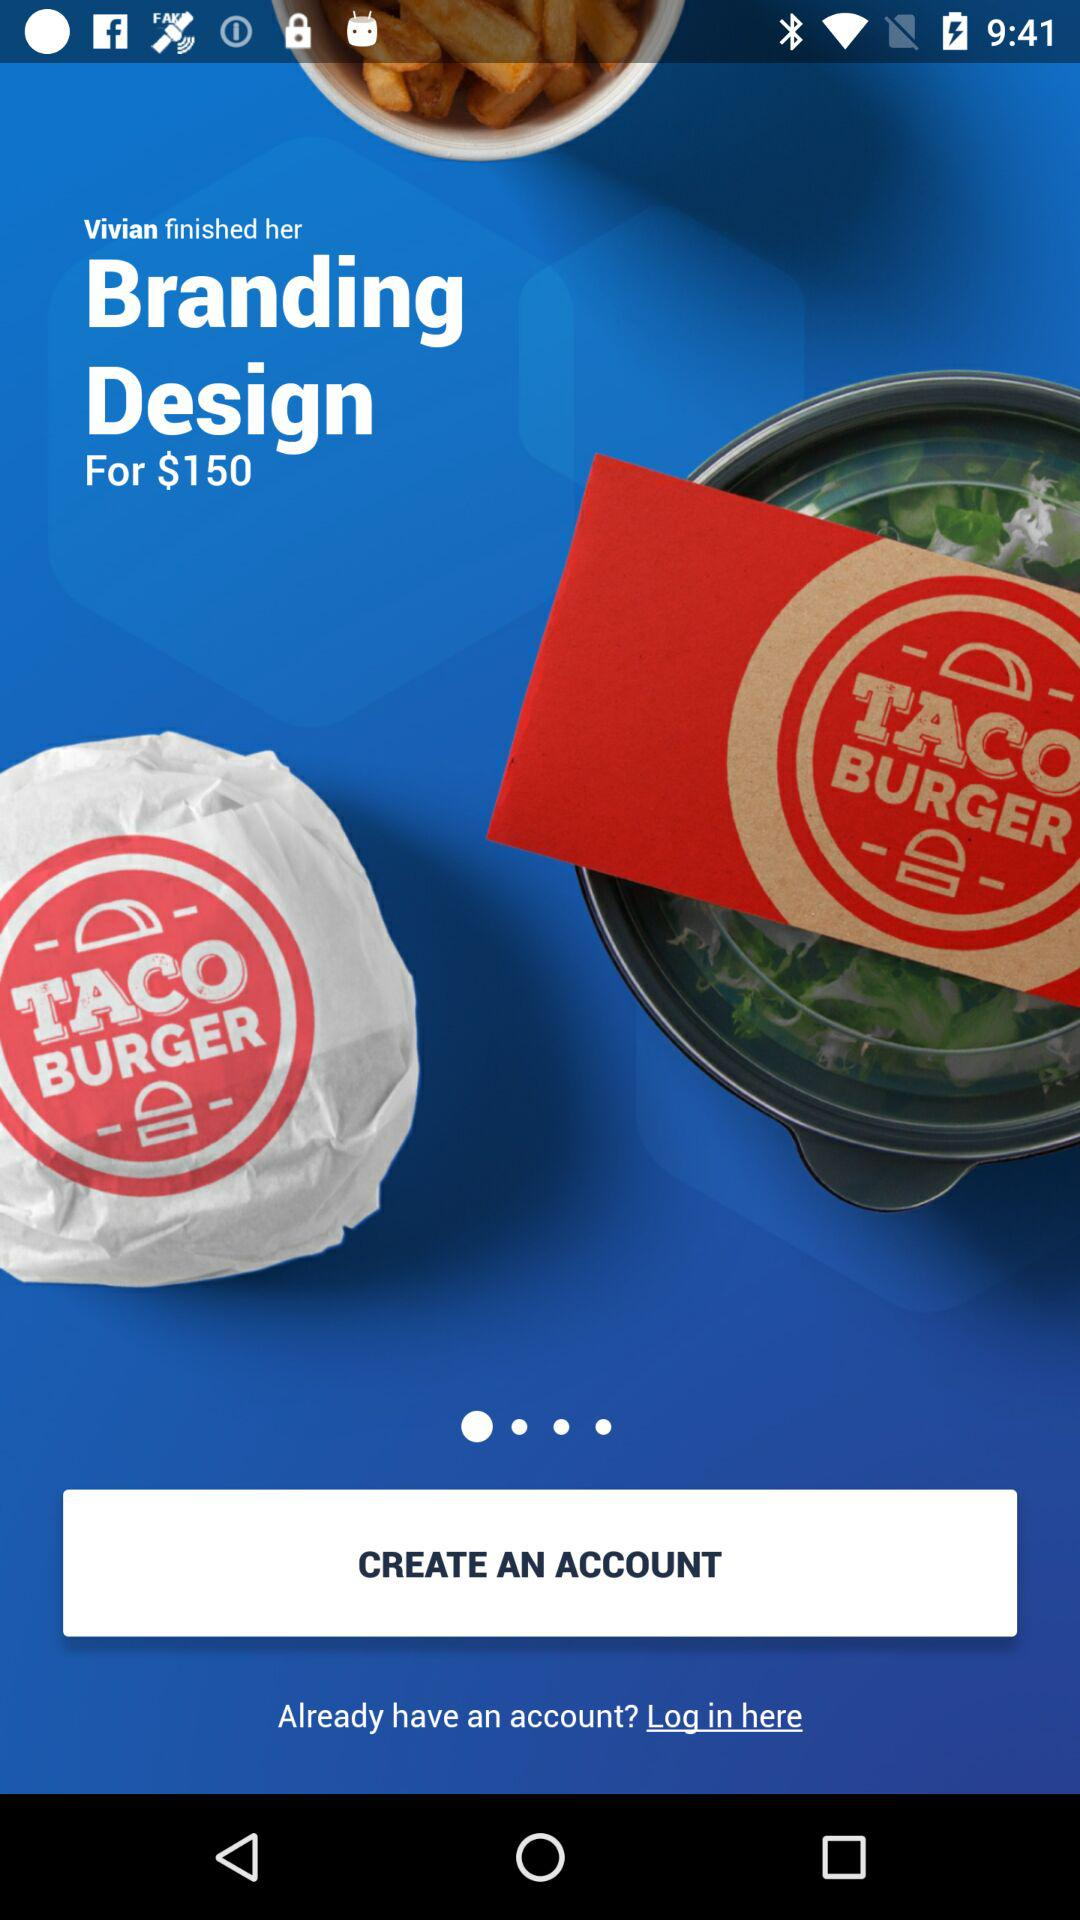What is the price of "Branding Design"? The price is $150. 